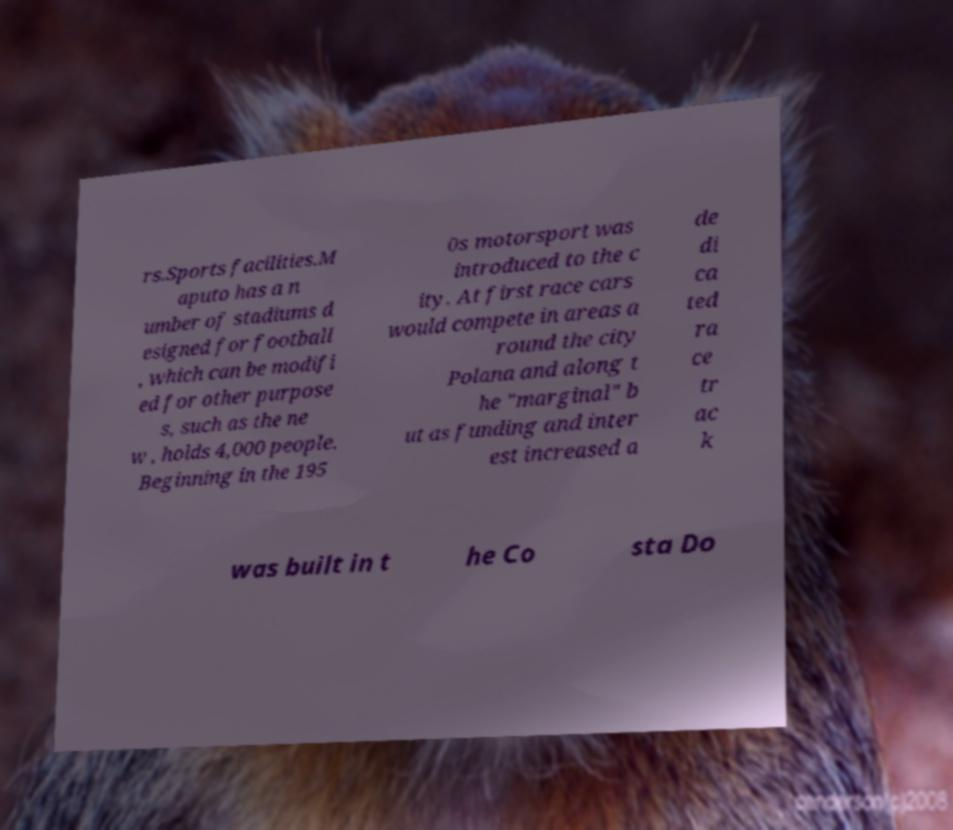Please read and relay the text visible in this image. What does it say? rs.Sports facilities.M aputo has a n umber of stadiums d esigned for football , which can be modifi ed for other purpose s, such as the ne w , holds 4,000 people. Beginning in the 195 0s motorsport was introduced to the c ity. At first race cars would compete in areas a round the city Polana and along t he "marginal" b ut as funding and inter est increased a de di ca ted ra ce tr ac k was built in t he Co sta Do 